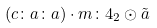Convert formula to latex. <formula><loc_0><loc_0><loc_500><loc_500>( c \colon a \colon a ) \cdot m \colon 4 _ { 2 } \odot \tilde { a }</formula> 